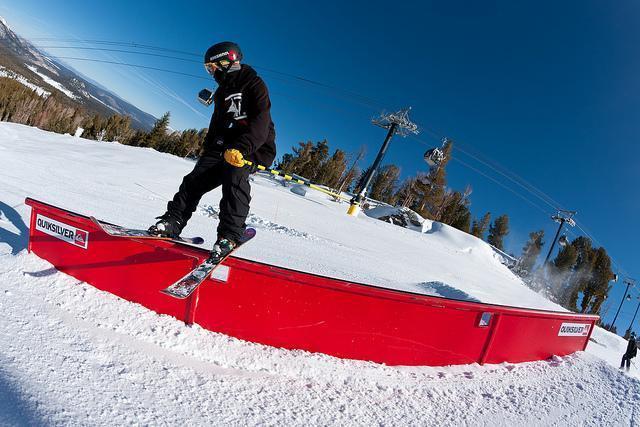How many bottles of wine?
Give a very brief answer. 0. 